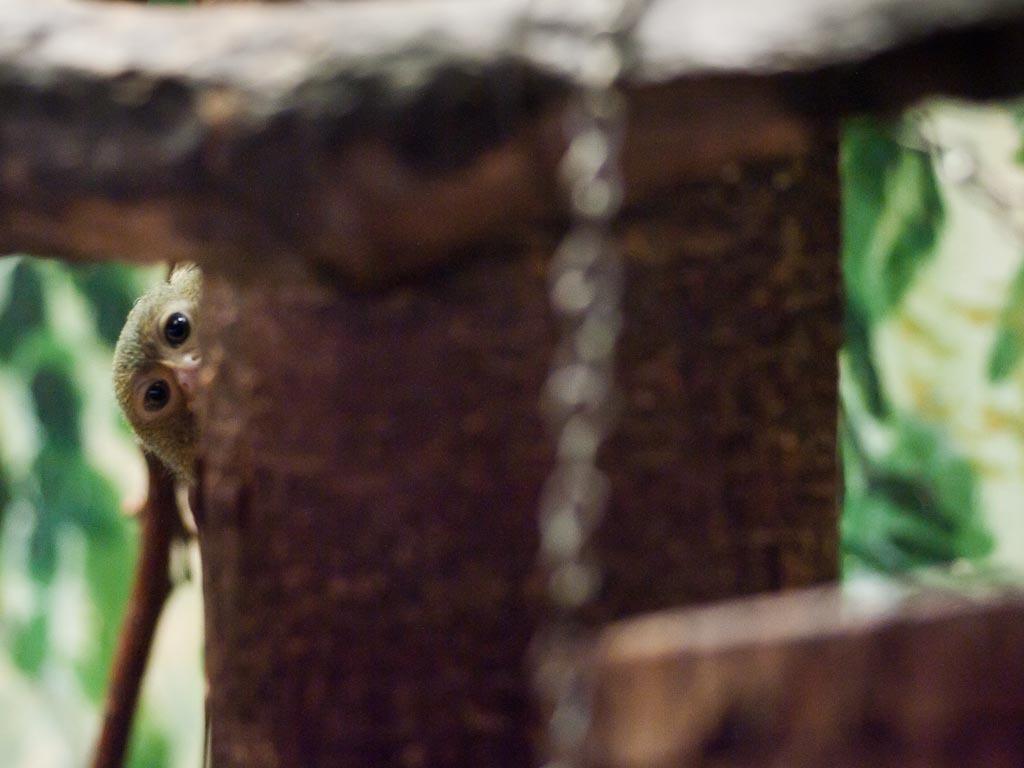In one or two sentences, can you explain what this image depicts? In this picture we can observe a monkey behind this tree. We can observe wooden railing here. In the background it is completely blur. 